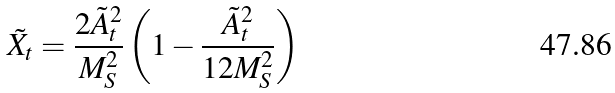Convert formula to latex. <formula><loc_0><loc_0><loc_500><loc_500>\tilde { X } _ { t } = \frac { 2 \tilde { A } _ { t } ^ { 2 } } { M _ { S } ^ { 2 } } \left ( 1 - \frac { \tilde { A } _ { t } ^ { 2 } } { 1 2 M _ { S } ^ { 2 } } \right )</formula> 